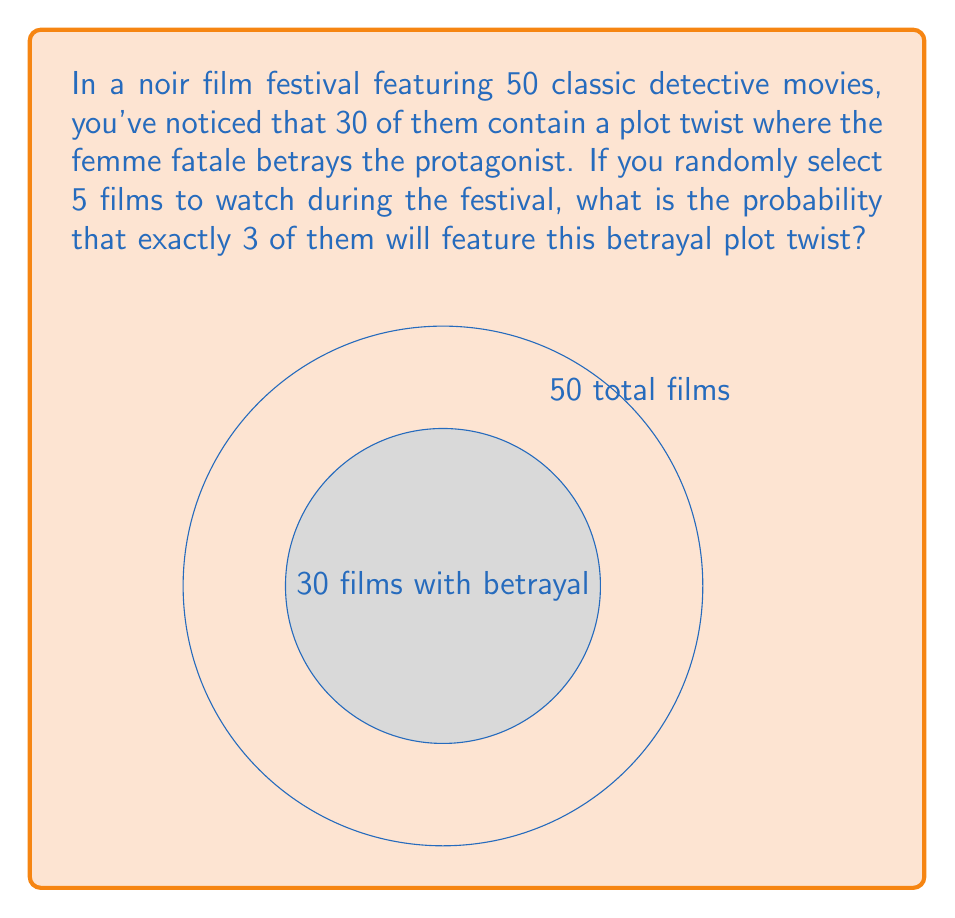Can you solve this math problem? Let's approach this step-by-step using the binomial probability formula:

1) This scenario follows a binomial distribution because:
   - We have a fixed number of trials (selecting 5 films)
   - Each trial has two possible outcomes (betrayal or no betrayal)
   - The probability of success (betrayal) is constant for each trial
   - The trials are independent

2) The probability of selecting a film with the betrayal plot twist is:
   $p = \frac{30}{50} = 0.6$

3) The probability of selecting a film without the betrayal is:
   $q = 1 - p = 1 - 0.6 = 0.4$

4) We want exactly 3 successes out of 5 trials. We can use the binomial probability formula:

   $$P(X = k) = \binom{n}{k} p^k (1-p)^{n-k}$$

   Where:
   $n = 5$ (total number of films selected)
   $k = 3$ (number of films with betrayal we want)
   $p = 0.6$ (probability of selecting a film with betrayal)

5) Substituting these values:

   $$P(X = 3) = \binom{5}{3} (0.6)^3 (0.4)^2$$

6) Calculate the binomial coefficient:
   $$\binom{5}{3} = \frac{5!}{3!(5-3)!} = \frac{5 \cdot 4}{2 \cdot 1} = 10$$

7) Now we can compute:
   $$P(X = 3) = 10 \cdot (0.6)^3 \cdot (0.4)^2$$
   $$= 10 \cdot 0.216 \cdot 0.16$$
   $$= 0.3456$$

Therefore, the probability of selecting exactly 3 films with the betrayal plot twist out of 5 randomly selected noir films is approximately 0.3456 or 34.56%.
Answer: 0.3456 